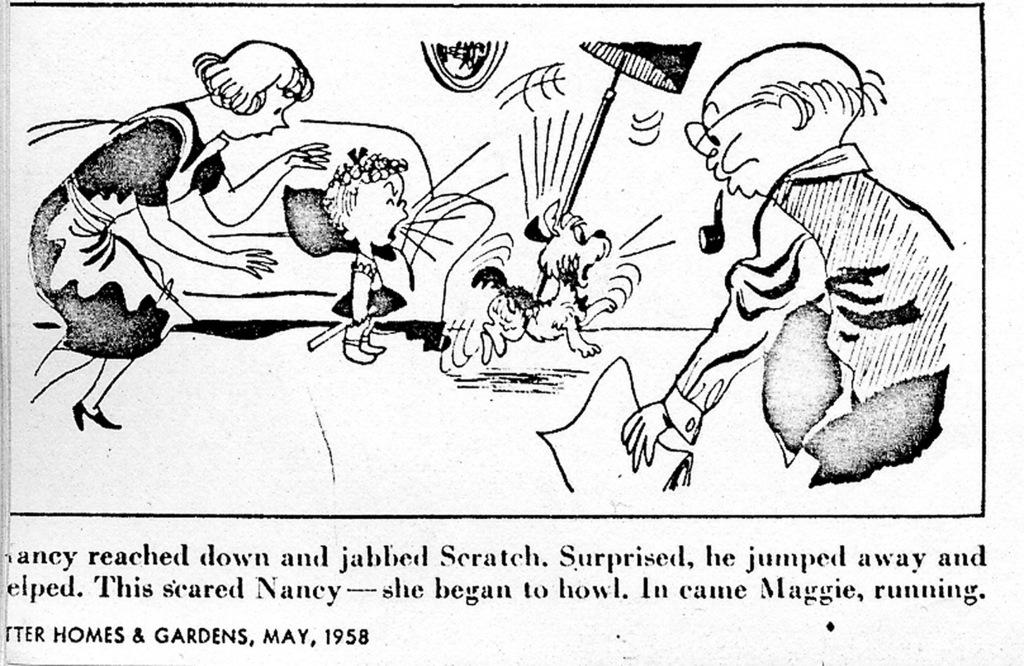What is present in the image that features visual content? There is a poster in the image. What can be seen on the poster? There are images on the poster. What else is present on the poster besides the images? There is writing on the poster. What type of iron can be seen in the image? There is no iron present in the image; it features a poster with images and writing. How many planes are depicted on the poster in the image? There is no information about planes on the poster in the image. 